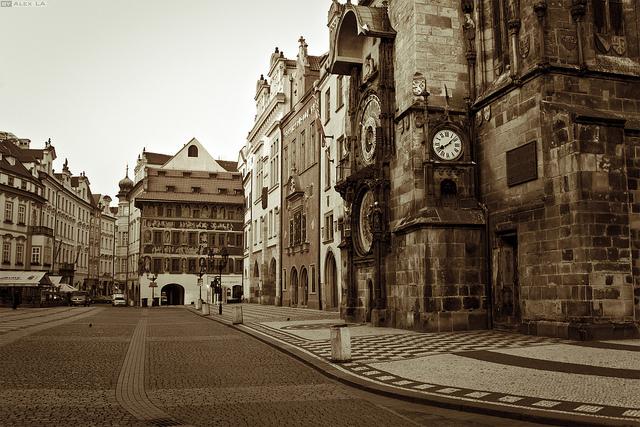Is the picture black and white?
Quick response, please. Yes. Can you see a clock anywhere in the picture?
Concise answer only. Yes. Is the road bricked?
Keep it brief. Yes. Is there traffic?
Quick response, please. No. 